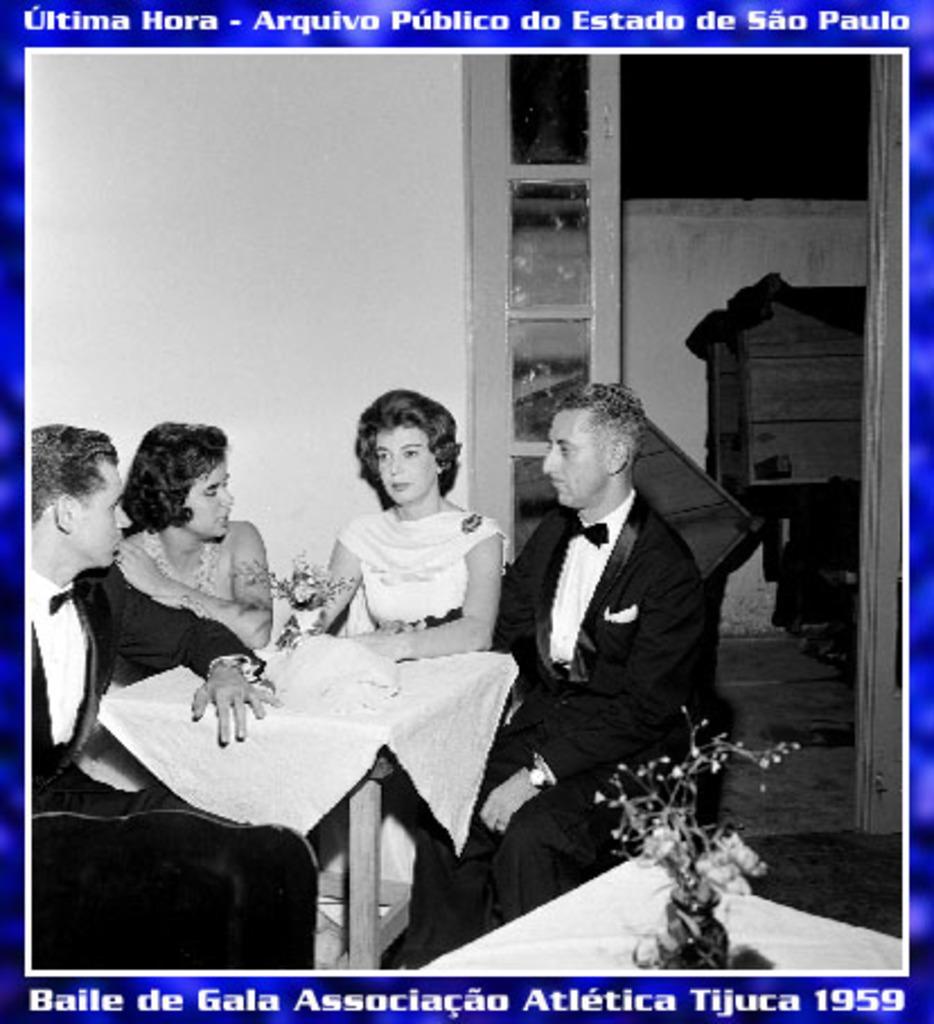How would you summarize this image in a sentence or two? This is a black and white image. In this image we can see persons sitting on the chairs, flower vase, walls and a cupboard. At the top and bottom of the image we can see colored background and text. 